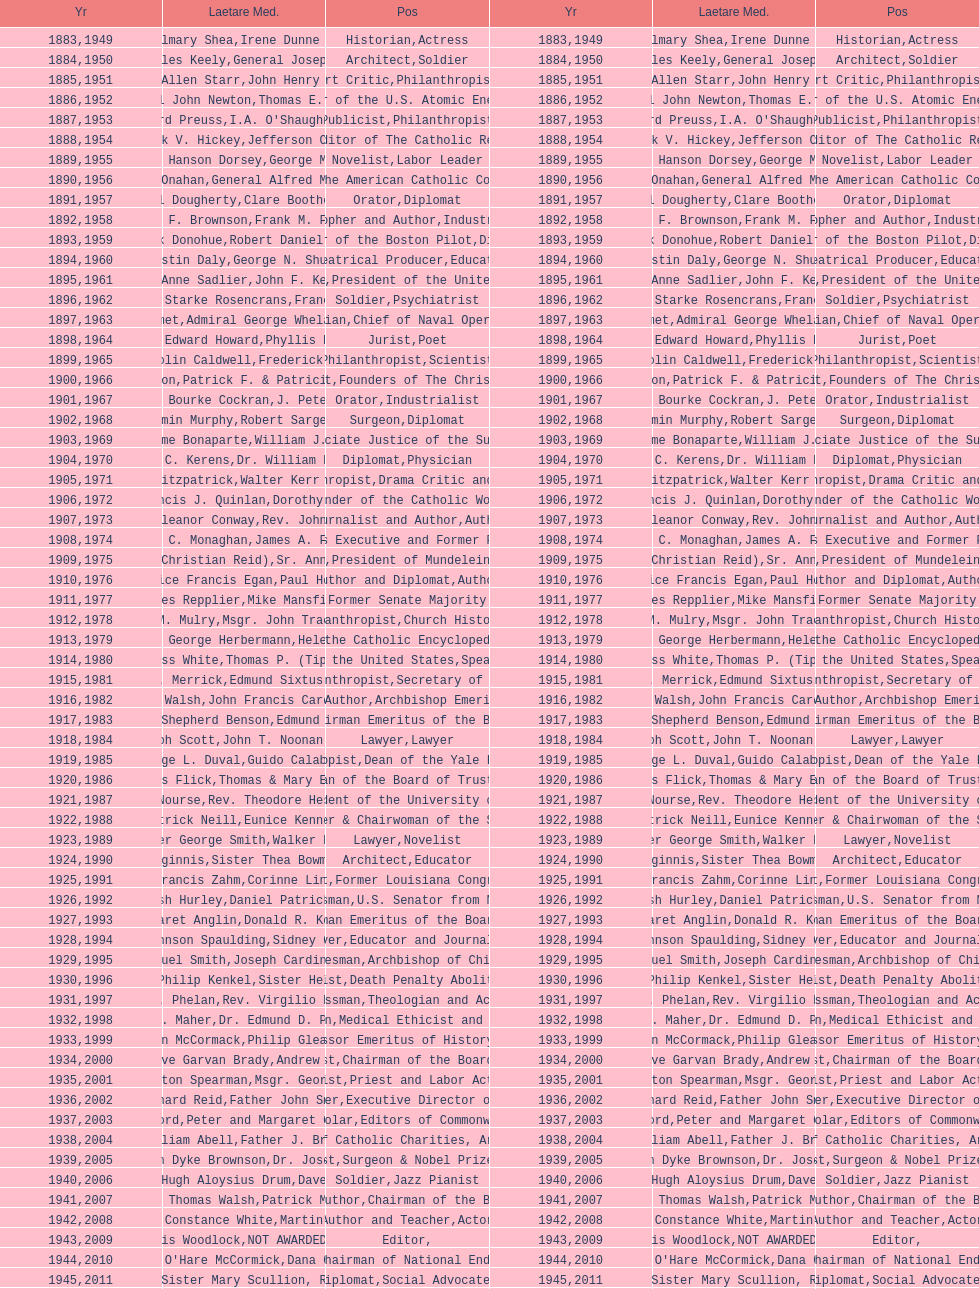How many lawyers have won the award between 1883 and 2014? 5. 